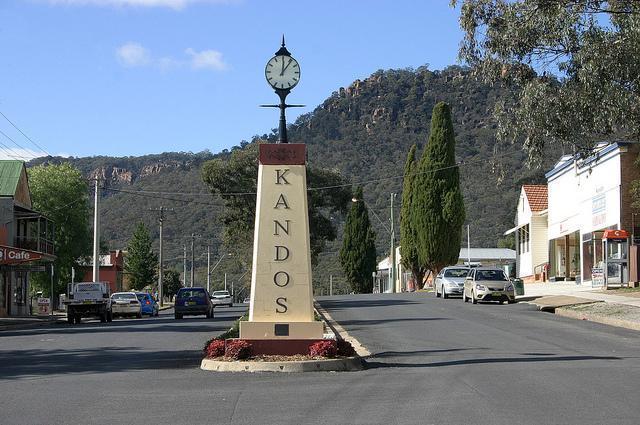What animal is native to this country?
Make your selection and explain in format: 'Answer: answer
Rationale: rationale.'
Options: Camel, polar bear, panda, kangaroo. Answer: kangaroo.
Rationale: The country can be inferred based on the name of the town written on the post in the image. of the list of answers, a is indigenous to the country of kandos. 